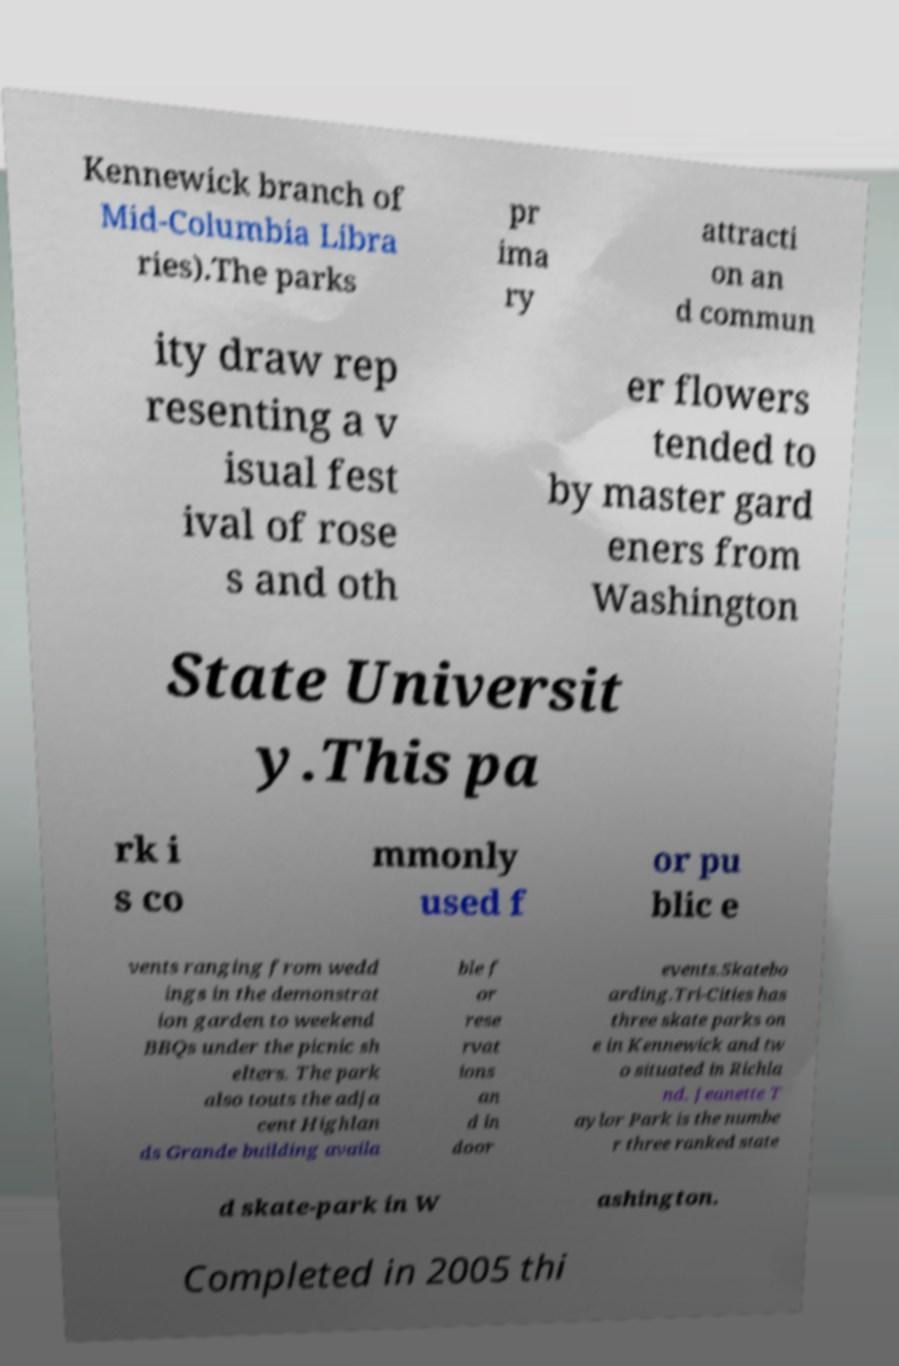Please identify and transcribe the text found in this image. Kennewick branch of Mid-Columbia Libra ries).The parks pr ima ry attracti on an d commun ity draw rep resenting a v isual fest ival of rose s and oth er flowers tended to by master gard eners from Washington State Universit y.This pa rk i s co mmonly used f or pu blic e vents ranging from wedd ings in the demonstrat ion garden to weekend BBQs under the picnic sh elters. The park also touts the adja cent Highlan ds Grande building availa ble f or rese rvat ions an d in door events.Skatebo arding.Tri-Cities has three skate parks on e in Kennewick and tw o situated in Richla nd. Jeanette T aylor Park is the numbe r three ranked state d skate-park in W ashington. Completed in 2005 thi 